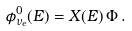Convert formula to latex. <formula><loc_0><loc_0><loc_500><loc_500>\phi _ { \nu _ { e } } ^ { 0 } ( E ) = X ( E ) \, \Phi \, .</formula> 